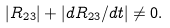Convert formula to latex. <formula><loc_0><loc_0><loc_500><loc_500>| R _ { 2 3 } | + | d R _ { 2 3 } / d t | \ne 0 .</formula> 